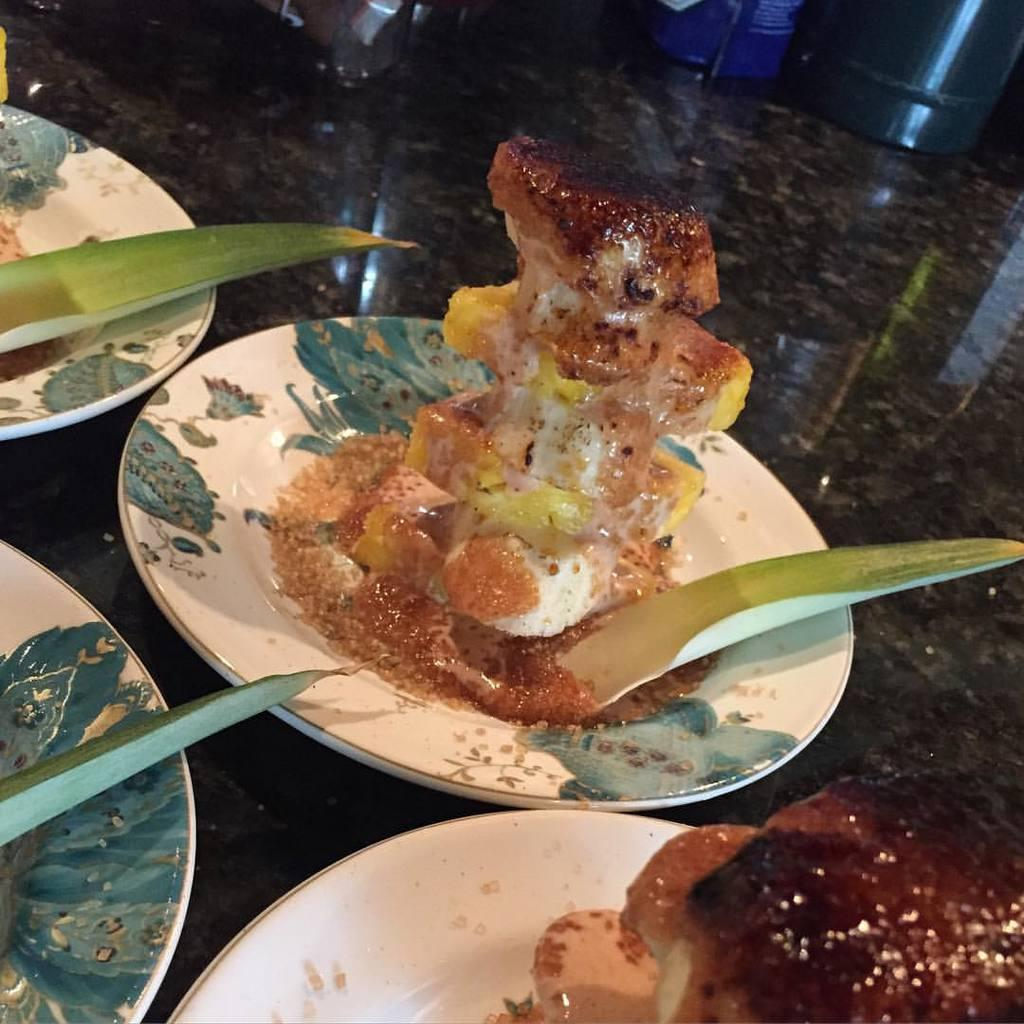What is on the table in the image? There are plates on a marble table in the image. What type of food can be seen on one of the plates? There is pastry on a plate in the image. What type of rose is being used as a garnish on the pastry in the image? There is no rose present in the image; it features plates with pastry on a marble table. 